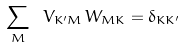Convert formula to latex. <formula><loc_0><loc_0><loc_500><loc_500>\sum _ { M } \ V _ { K ^ { \prime } M } \, W _ { M K } = \delta _ { K K ^ { \prime } }</formula> 